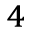<formula> <loc_0><loc_0><loc_500><loc_500>_ { 4 }</formula> 